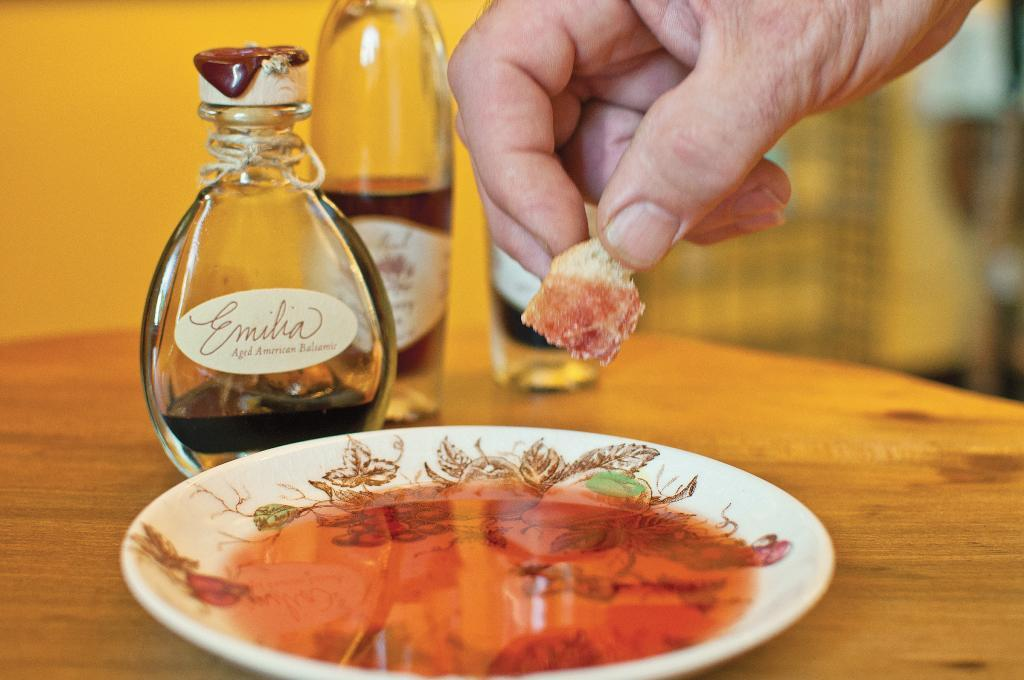<image>
Write a terse but informative summary of the picture. Emilia Aged American Balsamic Vinegar that is used for dipping. 